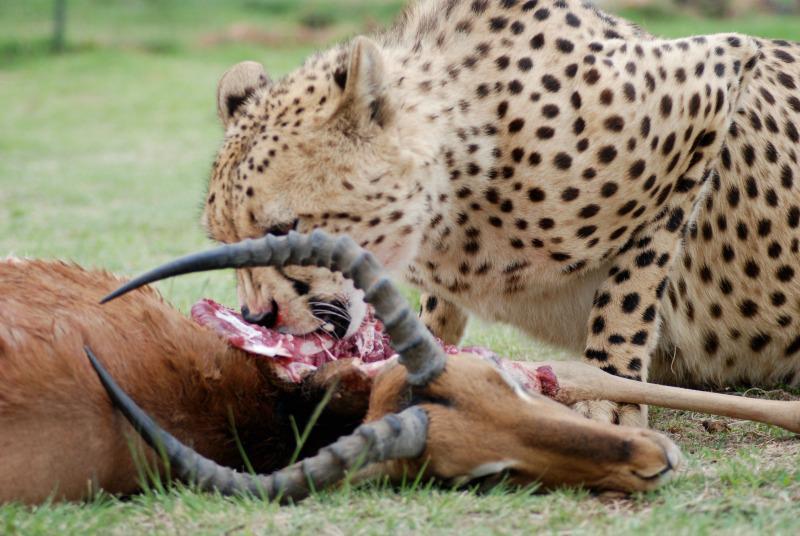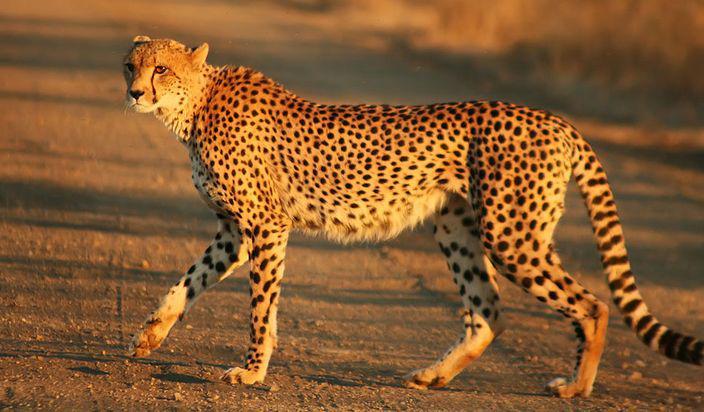The first image is the image on the left, the second image is the image on the right. For the images displayed, is the sentence "One of the big cats is running very fast and the others are eating." factually correct? Answer yes or no. No. 